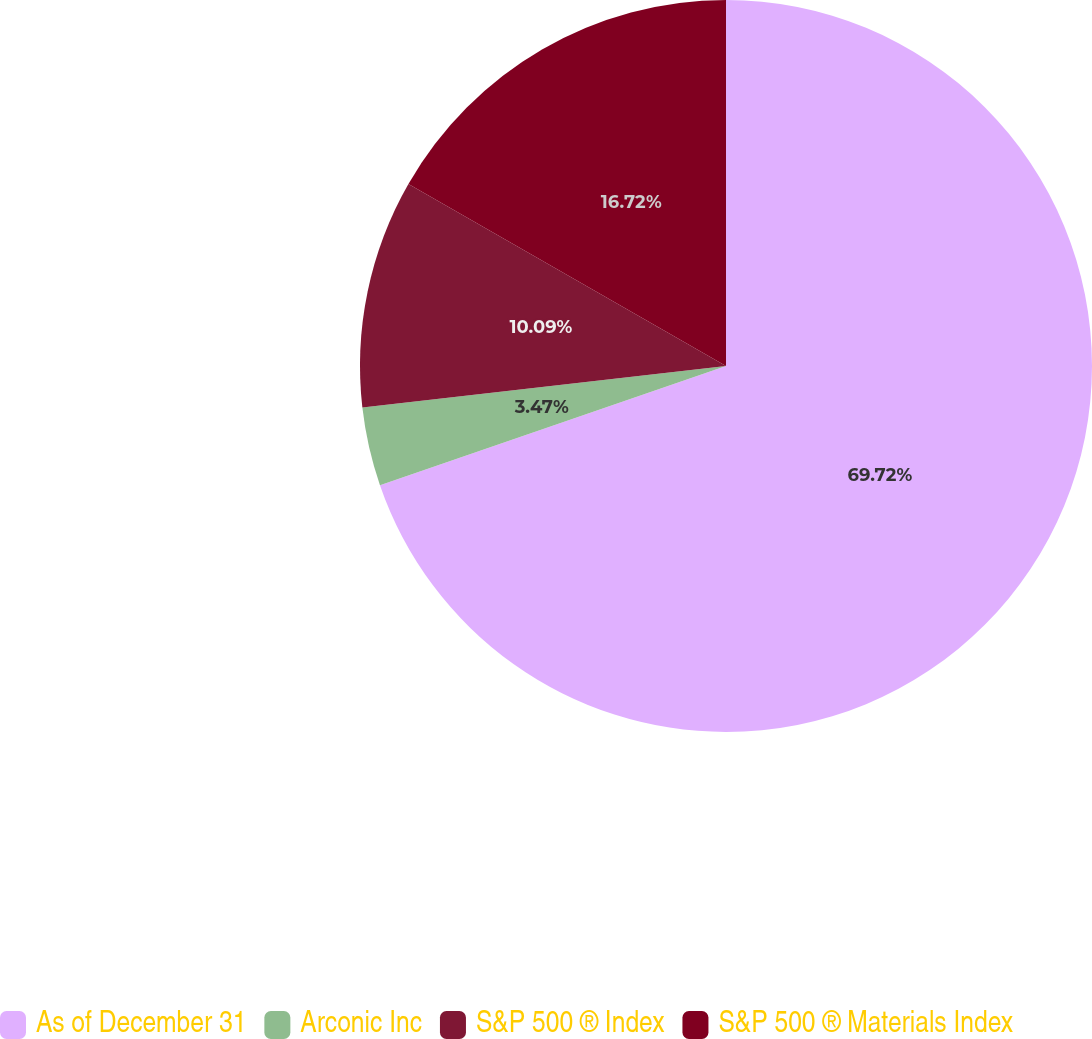Convert chart to OTSL. <chart><loc_0><loc_0><loc_500><loc_500><pie_chart><fcel>As of December 31<fcel>Arconic Inc<fcel>S&P 500 ® Index<fcel>S&P 500 ® Materials Index<nl><fcel>69.72%<fcel>3.47%<fcel>10.09%<fcel>16.72%<nl></chart> 